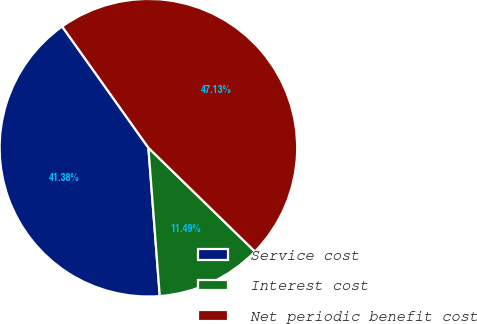<chart> <loc_0><loc_0><loc_500><loc_500><pie_chart><fcel>Service cost<fcel>Interest cost<fcel>Net periodic benefit cost<nl><fcel>41.38%<fcel>11.49%<fcel>47.13%<nl></chart> 